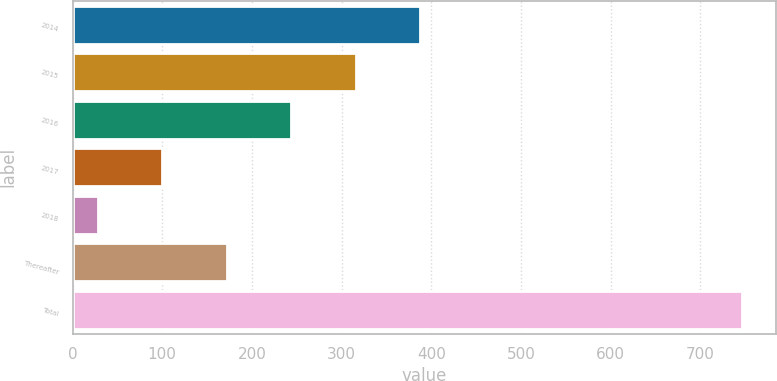Convert chart. <chart><loc_0><loc_0><loc_500><loc_500><bar_chart><fcel>2014<fcel>2015<fcel>2016<fcel>2017<fcel>2018<fcel>Thereafter<fcel>Total<nl><fcel>387.5<fcel>315.6<fcel>243.7<fcel>99.9<fcel>28<fcel>171.8<fcel>747<nl></chart> 